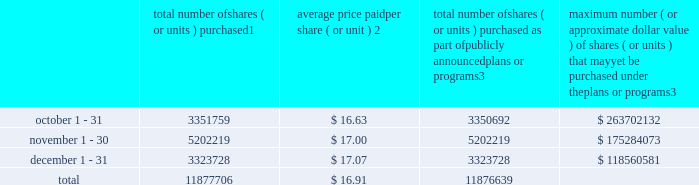Transfer agent and registrar for common stock the transfer agent and registrar for our common stock is : computershare shareowner services llc 480 washington boulevard 29th floor jersey city , new jersey 07310 telephone : ( 877 ) 363-6398 sales of unregistered securities not applicable .
Repurchase of equity securities the table provides information regarding our purchases of our equity securities during the period from october 1 , 2013 to december 31 , 2013 .
Total number of shares ( or units ) purchased 1 average price paid per share ( or unit ) 2 total number of shares ( or units ) purchased as part of publicly announced plans or programs 3 maximum number ( or approximate dollar value ) of shares ( or units ) that may yet be purchased under the plans or programs 3 .
1 includes shares of our common stock , par value $ 0.10 per share , withheld under the terms of grants under employee stock-based compensation plans to offset tax withholding obligations that occurred upon vesting and release of restricted shares ( the 201cwithheld shares 201d ) .
We repurchased 1067 withheld shares in october 2013 .
No withheld shares were purchased in november or december of 2013 .
2 the average price per share for each of the months in the fiscal quarter and for the three-month period was calculated by dividing the sum of the applicable period of the aggregate value of the tax withholding obligations and the aggregate amount we paid for shares acquired under our stock repurchase program , described in note 6 to the consolidated financial statements , by the sum of the number of withheld shares and the number of shares acquired in our stock repurchase program .
3 in february 2013 , the board authorized a new share repurchase program to repurchase from time to time up to $ 300.0 million , excluding fees , of our common stock ( the 201c2013 share repurchase program 201d ) .
In march 2013 , the board authorized an increase in the amount available under our 2013 share repurchase program up to $ 500.0 million , excluding fees , of our common stock .
On february 14 , 2014 , we announced that our board had approved a new share repurchase program to repurchase from time to time up to $ 300.0 million , excluding fees , of our common stock .
The new authorization is in addition to any amounts remaining available for repurchase under the 2013 share repurchase program .
There is no expiration date associated with the share repurchase programs. .
About how many more shares will the company still buy back in their repurchase plan if they paid $ 16.91 a share? 
Rationale: the amount of money left over is given on the right side of the table . we take that amount of money and divide it by the share price in order to get the amount of shares that can be bought .
Computations: (118560581 / 16.91)
Answer: 7011270.31342. 